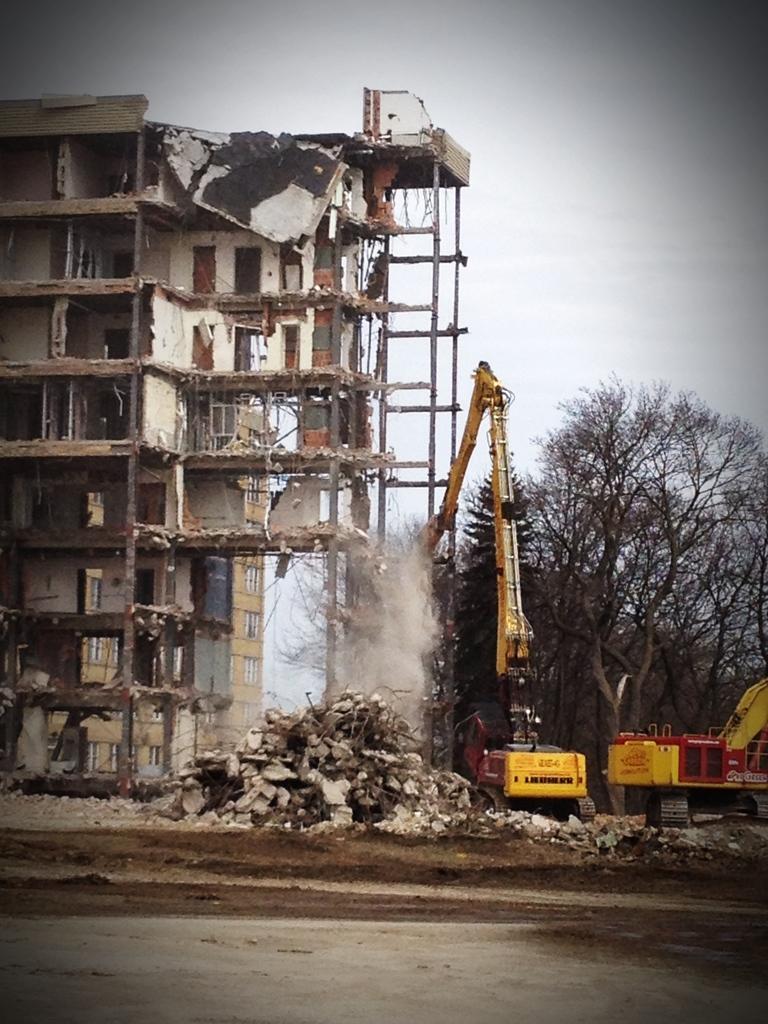Can you describe this image briefly? In this image I can see few buildings,windows,cranes,trees and few rocks. The sky is in white color. 